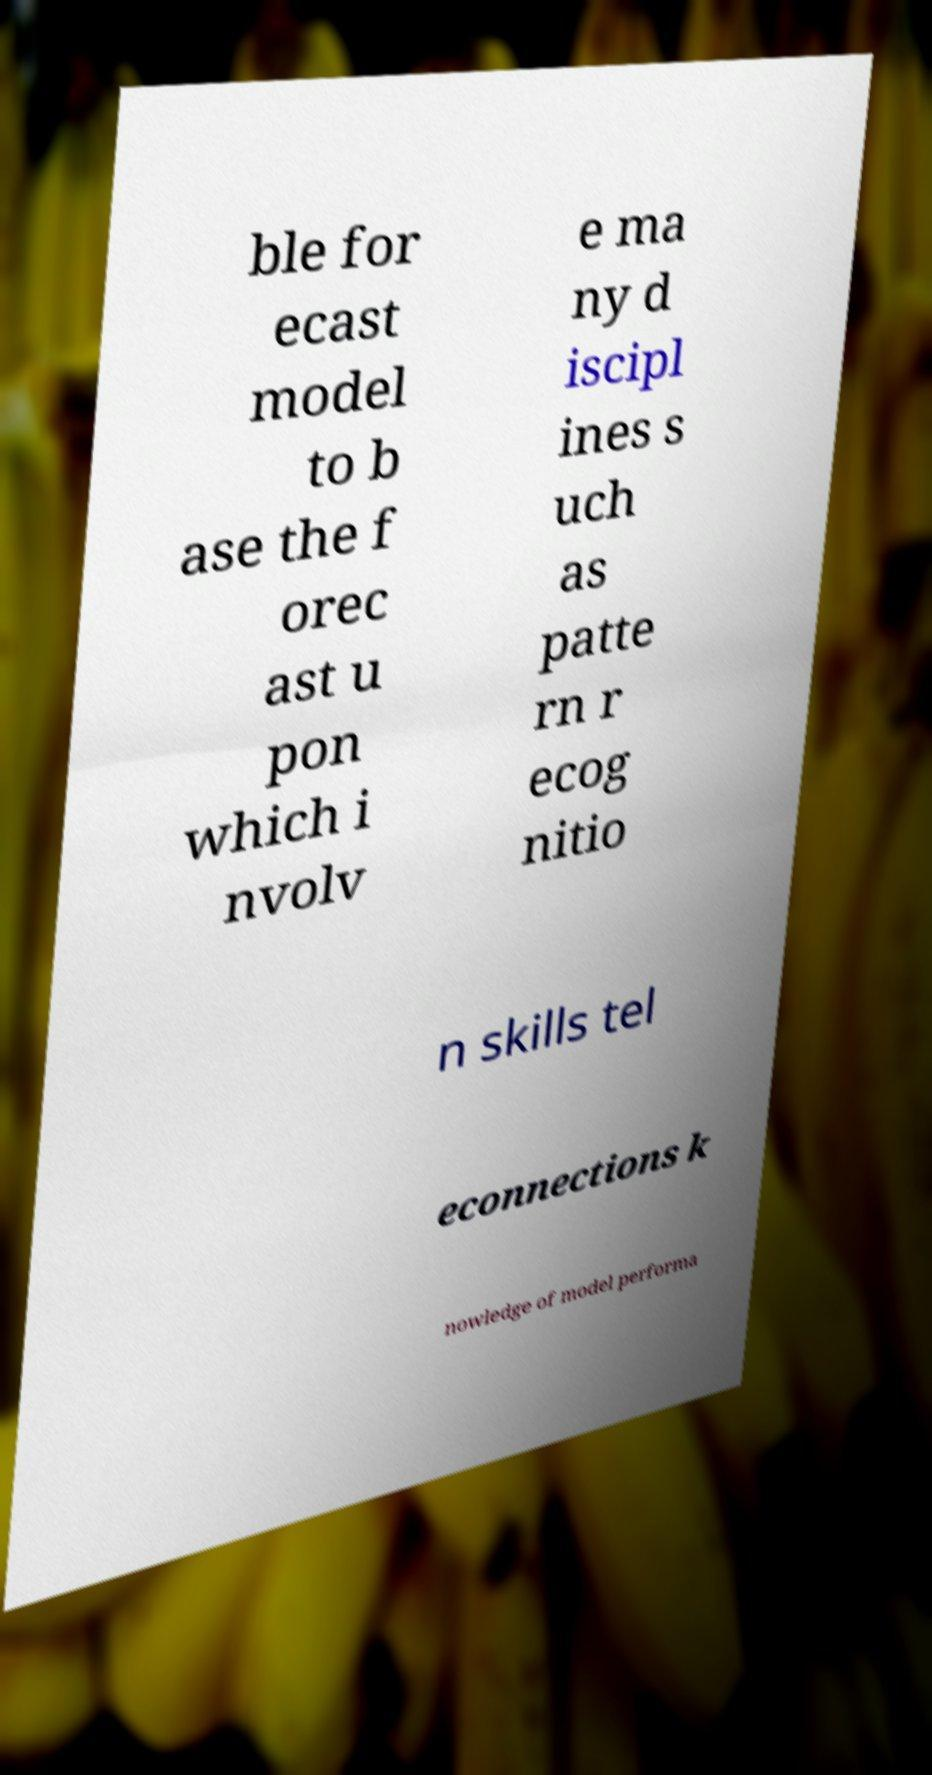I need the written content from this picture converted into text. Can you do that? ble for ecast model to b ase the f orec ast u pon which i nvolv e ma ny d iscipl ines s uch as patte rn r ecog nitio n skills tel econnections k nowledge of model performa 